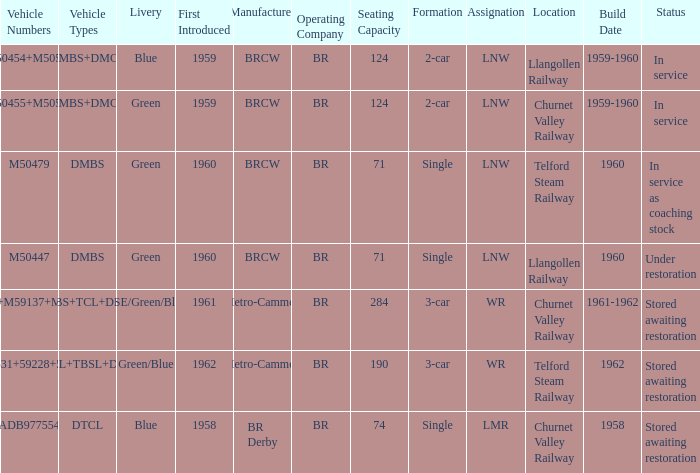What livery has a status of in service as coaching stock? Green. Could you help me parse every detail presented in this table? {'header': ['Vehicle Numbers', 'Vehicle Types', 'Livery', 'First Introduced', 'Manufacturer', 'Operating Company', 'Seating Capacity', 'Formation', 'Assignation', 'Location', 'Build Date', 'Status'], 'rows': [['M50454+M50528', 'DMBS+DMCL', 'Blue', '1959', 'BRCW', 'BR', '124', '2-car', 'LNW', 'Llangollen Railway', '1959-1960', 'In service'], ['M50455+M50517', 'DMBS+DMCL', 'Green', '1959', 'BRCW', 'BR', '124', '2-car', 'LNW', 'Churnet Valley Railway', '1959-1960', 'In service'], ['M50479', 'DMBS', 'Green', '1960', 'BRCW', 'BR', '71', 'Single', 'LNW', 'Telford Steam Railway', '1960', 'In service as coaching stock'], ['M50447', 'DMBS', 'Green', '1960', 'BRCW', 'BR', '71', 'Single', 'LNW', 'Llangollen Railway', '1960', 'Under restoration'], ['53437+M59137+M53494', 'DMBS+TCL+DMCL', 'NSE/Green/Blue', '1961', 'Metro-Cammell', 'BR', '284', '3-car', 'WR', 'Churnet Valley Railway', '1961-1962', 'Stored awaiting restoration'], ['M50531+59228+53556', 'DMCL+TBSL+DMCL', 'Green/Blue', '1962', 'Metro-Cammell', 'BR', '190', '3-car', 'WR', 'Telford Steam Railway', '1962', 'Stored awaiting restoration'], ['ADB977554', 'DTCL', 'Blue', '1958', 'BR Derby', 'BR', '74', 'Single', 'LMR', 'Churnet Valley Railway', '1958', 'Stored awaiting restoration']]} 